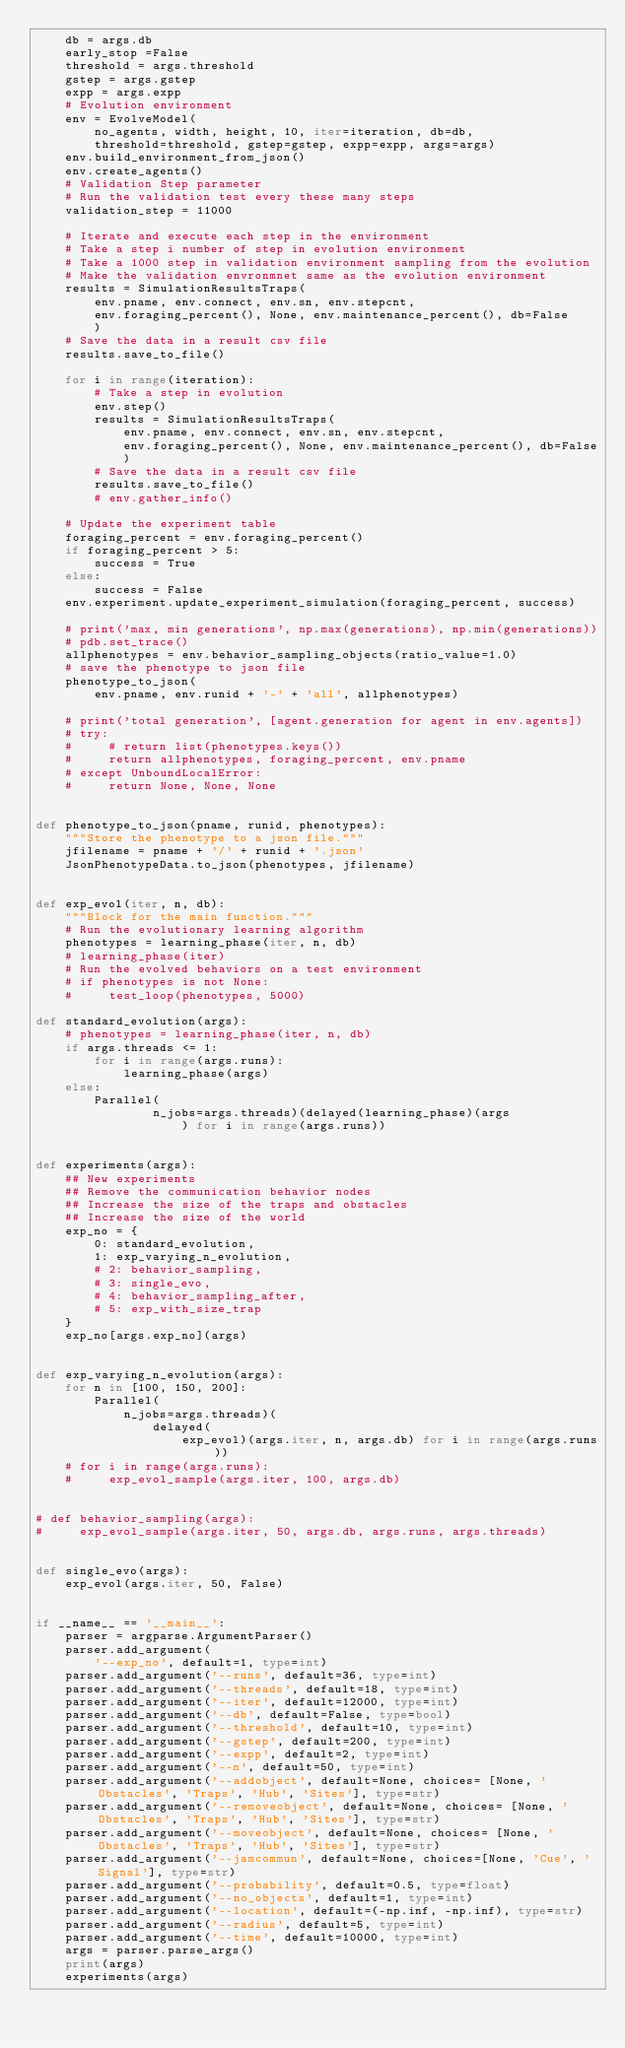Convert code to text. <code><loc_0><loc_0><loc_500><loc_500><_Python_>    db = args.db
    early_stop =False
    threshold = args.threshold
    gstep = args.gstep
    expp = args.expp
    # Evolution environment
    env = EvolveModel(
        no_agents, width, height, 10, iter=iteration, db=db,
        threshold=threshold, gstep=gstep, expp=expp, args=args)
    env.build_environment_from_json()
    env.create_agents()
    # Validation Step parameter
    # Run the validation test every these many steps
    validation_step = 11000

    # Iterate and execute each step in the environment
    # Take a step i number of step in evolution environment
    # Take a 1000 step in validation environment sampling from the evolution
    # Make the validation envronmnet same as the evolution environment
    results = SimulationResultsTraps(
        env.pname, env.connect, env.sn, env.stepcnt,
        env.foraging_percent(), None, env.maintenance_percent(), db=False
        )
    # Save the data in a result csv file
    results.save_to_file()

    for i in range(iteration):
        # Take a step in evolution
        env.step()
        results = SimulationResultsTraps(
            env.pname, env.connect, env.sn, env.stepcnt,
            env.foraging_percent(), None, env.maintenance_percent(), db=False
            )
        # Save the data in a result csv file
        results.save_to_file()
        # env.gather_info()

    # Update the experiment table
    foraging_percent = env.foraging_percent()
    if foraging_percent > 5:
        success = True
    else:
        success = False
    env.experiment.update_experiment_simulation(foraging_percent, success)

    # print('max, min generations', np.max(generations), np.min(generations))
    # pdb.set_trace()
    allphenotypes = env.behavior_sampling_objects(ratio_value=1.0)
    # save the phenotype to json file
    phenotype_to_json(
        env.pname, env.runid + '-' + 'all', allphenotypes)

    # print('total generation', [agent.generation for agent in env.agents])
    # try:
    #     # return list(phenotypes.keys())
    #     return allphenotypes, foraging_percent, env.pname
    # except UnboundLocalError:
    #     return None, None, None


def phenotype_to_json(pname, runid, phenotypes):
    """Store the phenotype to a json file."""
    jfilename = pname + '/' + runid + '.json'
    JsonPhenotypeData.to_json(phenotypes, jfilename)


def exp_evol(iter, n, db):
    """Block for the main function."""
    # Run the evolutionary learning algorithm
    phenotypes = learning_phase(iter, n, db)
    # learning_phase(iter)
    # Run the evolved behaviors on a test environment
    # if phenotypes is not None:
    #     test_loop(phenotypes, 5000)

def standard_evolution(args):
    # phenotypes = learning_phase(iter, n, db)
    if args.threads <= 1:
        for i in range(args.runs):
            learning_phase(args)
    else:
        Parallel(
                n_jobs=args.threads)(delayed(learning_phase)(args
                    ) for i in range(args.runs))


def experiments(args):
    ## New experiments
    ## Remove the communication behavior nodes
    ## Increase the size of the traps and obstacles
    ## Increase the size of the world
    exp_no = {
        0: standard_evolution,
        1: exp_varying_n_evolution,
        # 2: behavior_sampling,
        # 3: single_evo,
        # 4: behavior_sampling_after,
        # 5: exp_with_size_trap
    }
    exp_no[args.exp_no](args)


def exp_varying_n_evolution(args):
    for n in [100, 150, 200]:
        Parallel(
            n_jobs=args.threads)(
                delayed(
                    exp_evol)(args.iter, n, args.db) for i in range(args.runs))
    # for i in range(args.runs):
    #     exp_evol_sample(args.iter, 100, args.db)


# def behavior_sampling(args):
#     exp_evol_sample(args.iter, 50, args.db, args.runs, args.threads)


def single_evo(args):
    exp_evol(args.iter, 50, False)


if __name__ == '__main__':
    parser = argparse.ArgumentParser()
    parser.add_argument(
        '--exp_no', default=1, type=int)
    parser.add_argument('--runs', default=36, type=int)
    parser.add_argument('--threads', default=18, type=int)
    parser.add_argument('--iter', default=12000, type=int)
    parser.add_argument('--db', default=False, type=bool)
    parser.add_argument('--threshold', default=10, type=int)
    parser.add_argument('--gstep', default=200, type=int)
    parser.add_argument('--expp', default=2, type=int)
    parser.add_argument('--n', default=50, type=int)
    parser.add_argument('--addobject', default=None, choices= [None, 'Obstacles', 'Traps', 'Hub', 'Sites'], type=str)
    parser.add_argument('--removeobject', default=None, choices= [None, 'Obstacles', 'Traps', 'Hub', 'Sites'], type=str)
    parser.add_argument('--moveobject', default=None, choices= [None, 'Obstacles', 'Traps', 'Hub', 'Sites'], type=str)
    parser.add_argument('--jamcommun', default=None, choices=[None, 'Cue', 'Signal'], type=str)
    parser.add_argument('--probability', default=0.5, type=float)
    parser.add_argument('--no_objects', default=1, type=int)
    parser.add_argument('--location', default=(-np.inf, -np.inf), type=str)
    parser.add_argument('--radius', default=5, type=int)
    parser.add_argument('--time', default=10000, type=int)
    args = parser.parse_args()
    print(args)
    experiments(args)</code> 